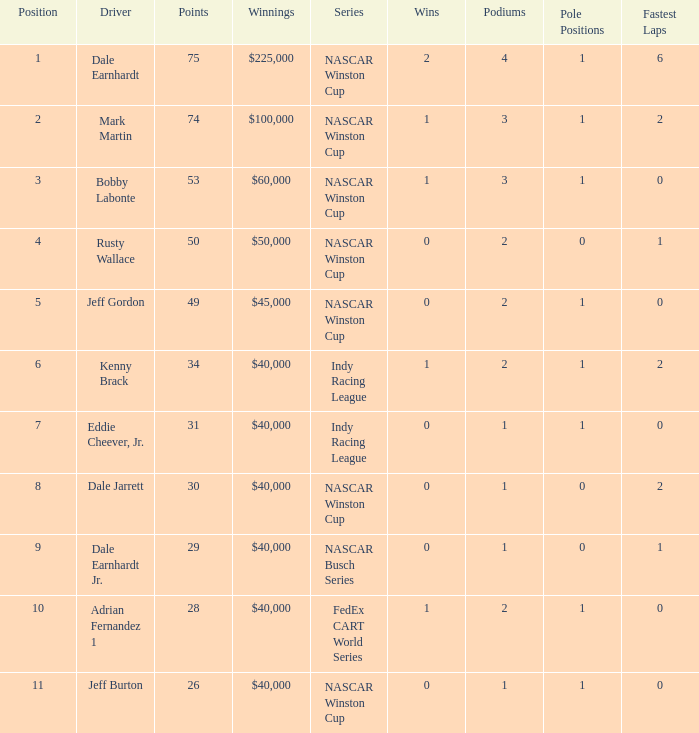How much did Kenny Brack win? $40,000. 